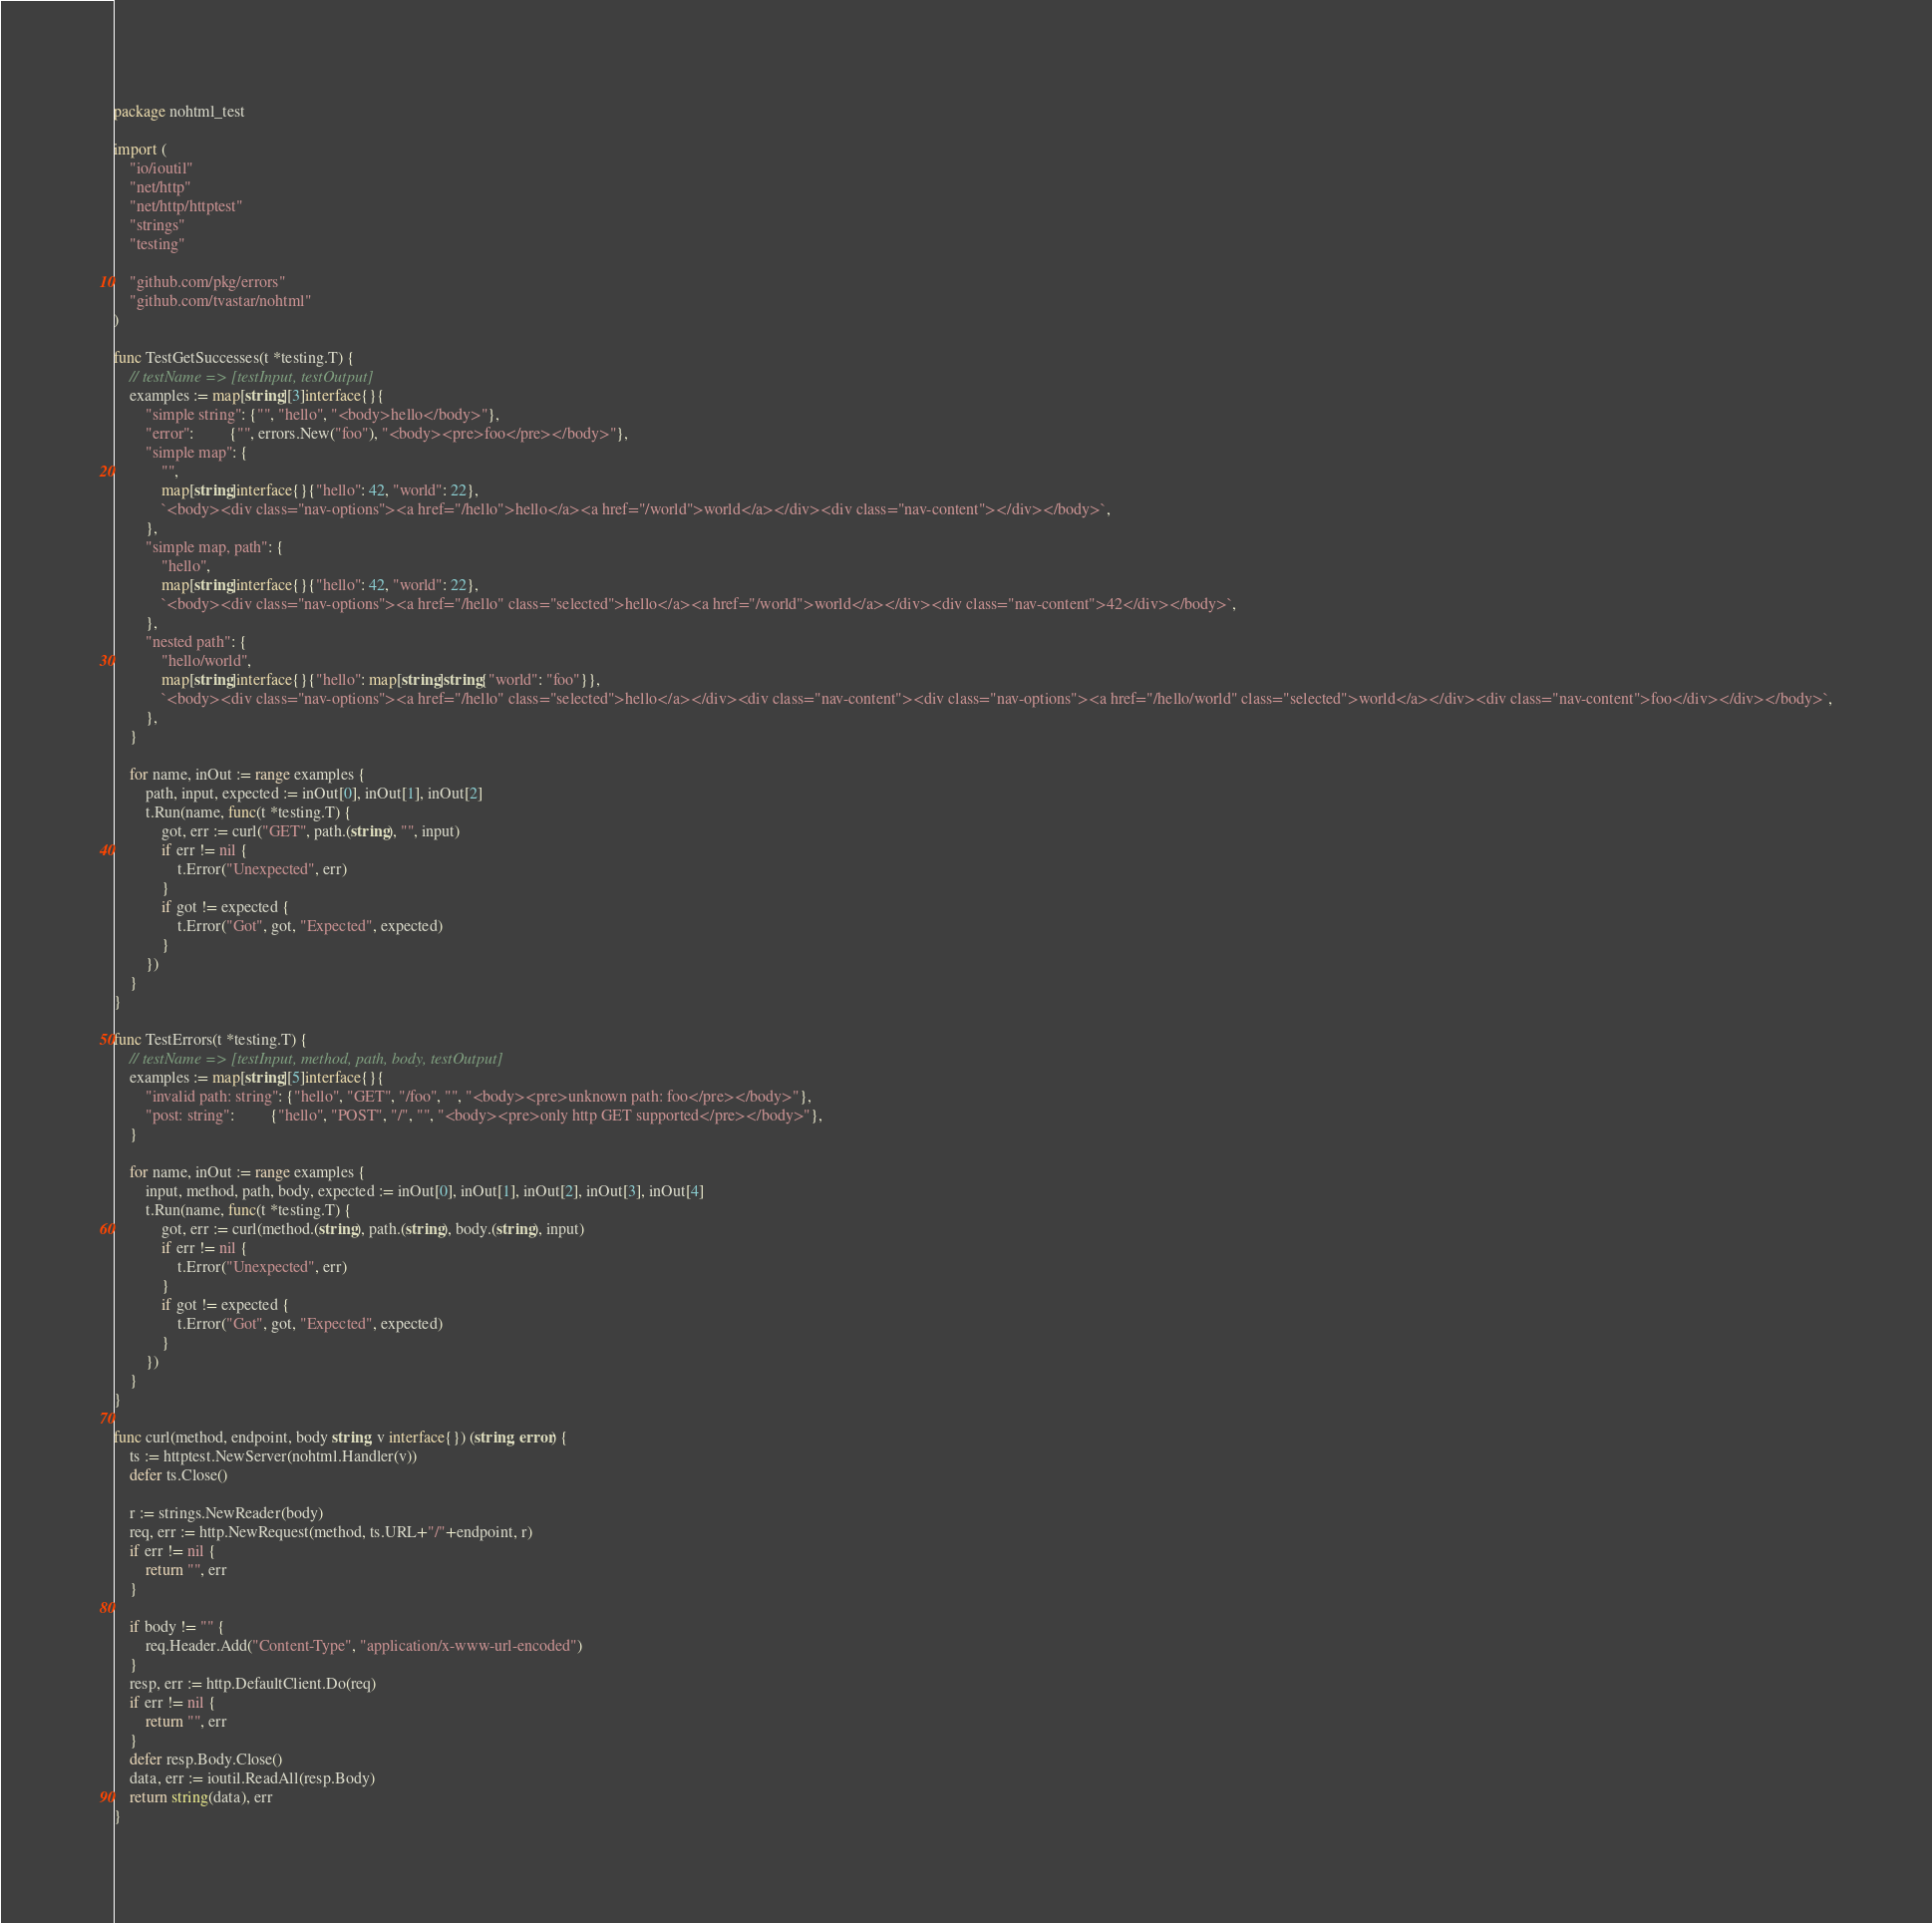<code> <loc_0><loc_0><loc_500><loc_500><_Go_>package nohtml_test

import (
	"io/ioutil"
	"net/http"
	"net/http/httptest"
	"strings"
	"testing"

	"github.com/pkg/errors"
	"github.com/tvastar/nohtml"
)

func TestGetSuccesses(t *testing.T) {
	// testName => [testInput, testOutput]
	examples := map[string][3]interface{}{
		"simple string": {"", "hello", "<body>hello</body>"},
		"error":         {"", errors.New("foo"), "<body><pre>foo</pre></body>"},
		"simple map": {
			"",
			map[string]interface{}{"hello": 42, "world": 22},
			`<body><div class="nav-options"><a href="/hello">hello</a><a href="/world">world</a></div><div class="nav-content"></div></body>`,
		},
		"simple map, path": {
			"hello",
			map[string]interface{}{"hello": 42, "world": 22},
			`<body><div class="nav-options"><a href="/hello" class="selected">hello</a><a href="/world">world</a></div><div class="nav-content">42</div></body>`,
		},
		"nested path": {
			"hello/world",
			map[string]interface{}{"hello": map[string]string{"world": "foo"}},
			`<body><div class="nav-options"><a href="/hello" class="selected">hello</a></div><div class="nav-content"><div class="nav-options"><a href="/hello/world" class="selected">world</a></div><div class="nav-content">foo</div></div></body>`,
		},
	}

	for name, inOut := range examples {
		path, input, expected := inOut[0], inOut[1], inOut[2]
		t.Run(name, func(t *testing.T) {
			got, err := curl("GET", path.(string), "", input)
			if err != nil {
				t.Error("Unexpected", err)
			}
			if got != expected {
				t.Error("Got", got, "Expected", expected)
			}
		})
	}
}

func TestErrors(t *testing.T) {
	// testName => [testInput, method, path, body, testOutput]
	examples := map[string][5]interface{}{
		"invalid path: string": {"hello", "GET", "/foo", "", "<body><pre>unknown path: foo</pre></body>"},
		"post: string":         {"hello", "POST", "/", "", "<body><pre>only http GET supported</pre></body>"},
	}

	for name, inOut := range examples {
		input, method, path, body, expected := inOut[0], inOut[1], inOut[2], inOut[3], inOut[4]
		t.Run(name, func(t *testing.T) {
			got, err := curl(method.(string), path.(string), body.(string), input)
			if err != nil {
				t.Error("Unexpected", err)
			}
			if got != expected {
				t.Error("Got", got, "Expected", expected)
			}
		})
	}
}

func curl(method, endpoint, body string, v interface{}) (string, error) {
	ts := httptest.NewServer(nohtml.Handler(v))
	defer ts.Close()

	r := strings.NewReader(body)
	req, err := http.NewRequest(method, ts.URL+"/"+endpoint, r)
	if err != nil {
		return "", err
	}

	if body != "" {
		req.Header.Add("Content-Type", "application/x-www-url-encoded")
	}
	resp, err := http.DefaultClient.Do(req)
	if err != nil {
		return "", err
	}
	defer resp.Body.Close()
	data, err := ioutil.ReadAll(resp.Body)
	return string(data), err
}
</code> 